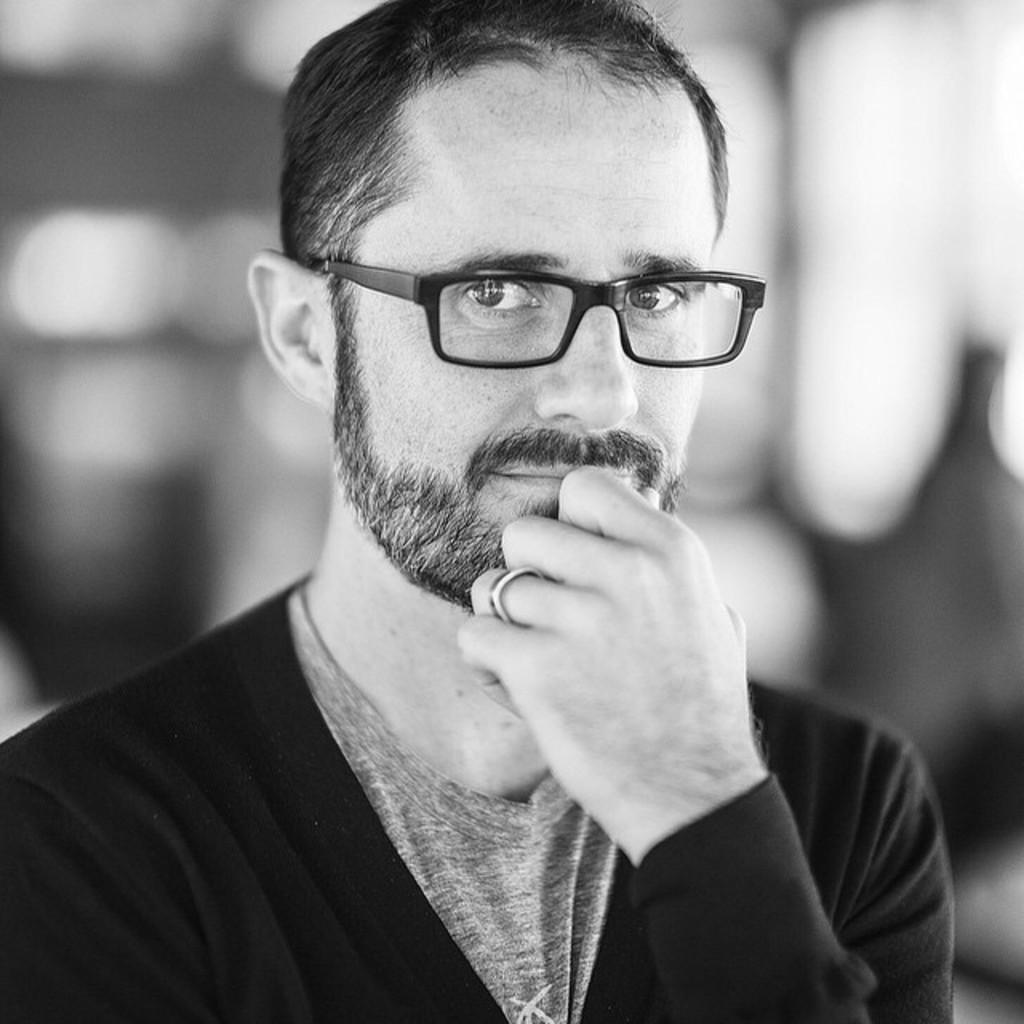Describe this image in one or two sentences. In this image I can see the black and white picture in which I can see a person wearing black colored dress and black colored spectacles. I can see the blurry background. 